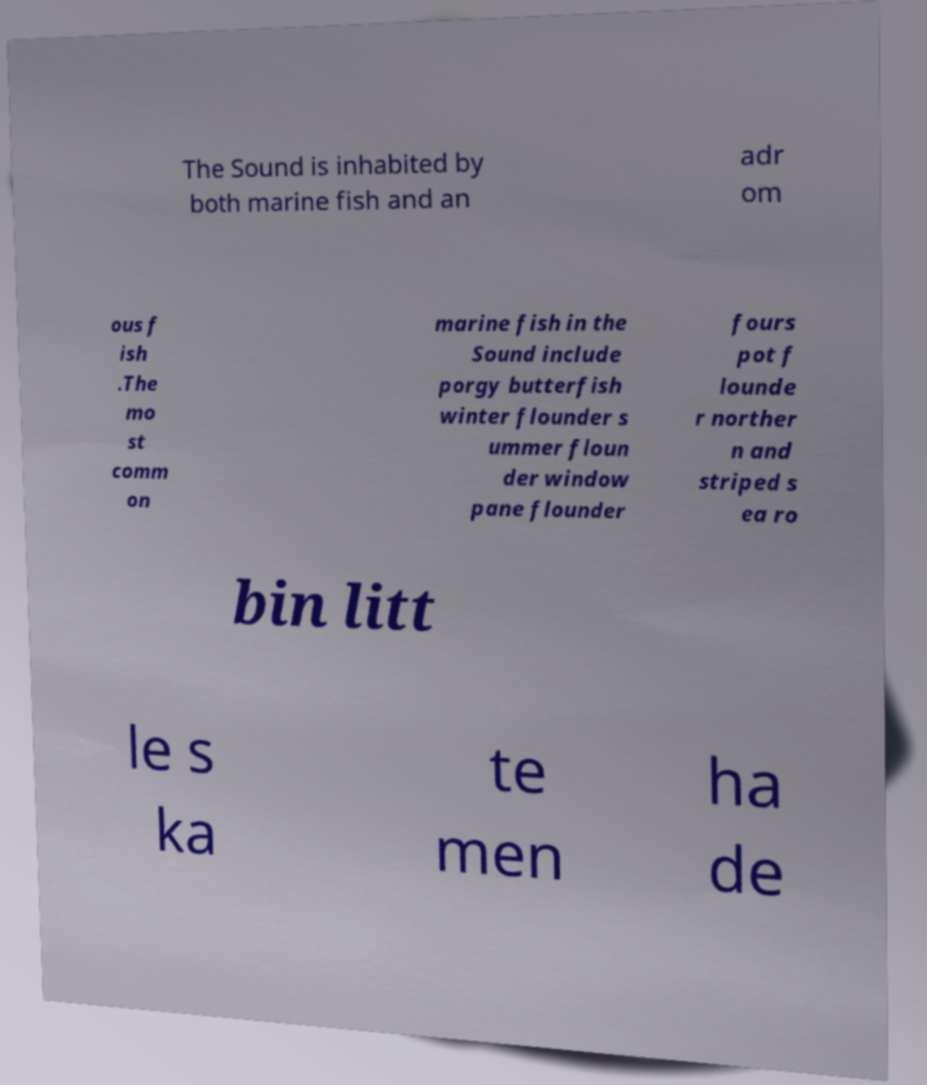Could you extract and type out the text from this image? The Sound is inhabited by both marine fish and an adr om ous f ish .The mo st comm on marine fish in the Sound include porgy butterfish winter flounder s ummer floun der window pane flounder fours pot f lounde r norther n and striped s ea ro bin litt le s ka te men ha de 